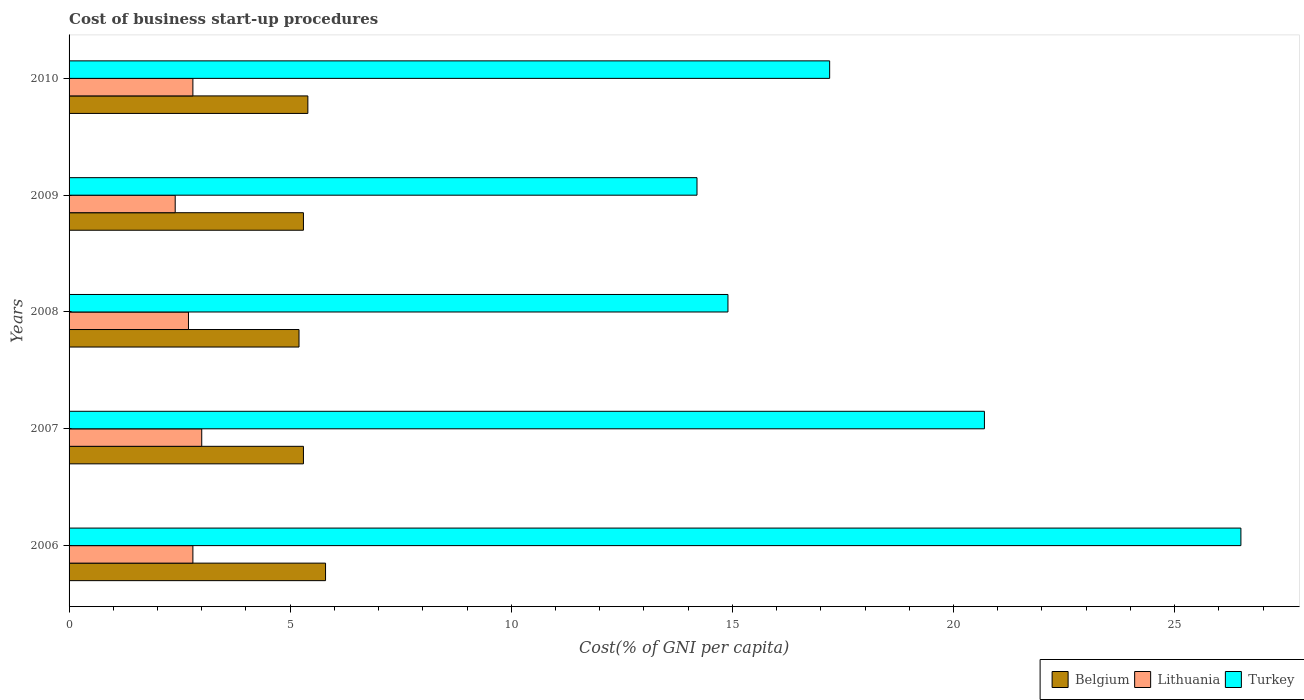How many groups of bars are there?
Provide a short and direct response. 5. Are the number of bars on each tick of the Y-axis equal?
Your answer should be compact. Yes. How many bars are there on the 4th tick from the top?
Your answer should be very brief. 3. What is the label of the 2nd group of bars from the top?
Your answer should be very brief. 2009. What is the total cost of business start-up procedures in Turkey in the graph?
Ensure brevity in your answer.  93.5. What is the difference between the cost of business start-up procedures in Belgium in 2008 and that in 2010?
Offer a very short reply. -0.2. What is the difference between the cost of business start-up procedures in Belgium in 2006 and the cost of business start-up procedures in Lithuania in 2008?
Give a very brief answer. 3.1. In the year 2006, what is the difference between the cost of business start-up procedures in Lithuania and cost of business start-up procedures in Belgium?
Keep it short and to the point. -3. In how many years, is the cost of business start-up procedures in Lithuania greater than 14 %?
Provide a succinct answer. 0. What is the ratio of the cost of business start-up procedures in Turkey in 2008 to that in 2009?
Ensure brevity in your answer.  1.05. Is the cost of business start-up procedures in Belgium in 2007 less than that in 2010?
Your response must be concise. Yes. Is the difference between the cost of business start-up procedures in Lithuania in 2006 and 2007 greater than the difference between the cost of business start-up procedures in Belgium in 2006 and 2007?
Offer a very short reply. No. What is the difference between the highest and the second highest cost of business start-up procedures in Lithuania?
Make the answer very short. 0.2. What is the difference between the highest and the lowest cost of business start-up procedures in Turkey?
Keep it short and to the point. 12.3. In how many years, is the cost of business start-up procedures in Belgium greater than the average cost of business start-up procedures in Belgium taken over all years?
Keep it short and to the point. 1. What does the 2nd bar from the top in 2008 represents?
Your answer should be very brief. Lithuania. What does the 1st bar from the bottom in 2006 represents?
Provide a succinct answer. Belgium. Is it the case that in every year, the sum of the cost of business start-up procedures in Lithuania and cost of business start-up procedures in Belgium is greater than the cost of business start-up procedures in Turkey?
Provide a succinct answer. No. What is the difference between two consecutive major ticks on the X-axis?
Ensure brevity in your answer.  5. Are the values on the major ticks of X-axis written in scientific E-notation?
Give a very brief answer. No. Does the graph contain any zero values?
Your response must be concise. No. Where does the legend appear in the graph?
Ensure brevity in your answer.  Bottom right. What is the title of the graph?
Your response must be concise. Cost of business start-up procedures. Does "Andorra" appear as one of the legend labels in the graph?
Make the answer very short. No. What is the label or title of the X-axis?
Provide a succinct answer. Cost(% of GNI per capita). What is the Cost(% of GNI per capita) of Belgium in 2006?
Your answer should be compact. 5.8. What is the Cost(% of GNI per capita) in Belgium in 2007?
Make the answer very short. 5.3. What is the Cost(% of GNI per capita) of Lithuania in 2007?
Keep it short and to the point. 3. What is the Cost(% of GNI per capita) of Turkey in 2007?
Give a very brief answer. 20.7. What is the Cost(% of GNI per capita) of Belgium in 2008?
Your answer should be very brief. 5.2. What is the Cost(% of GNI per capita) in Turkey in 2008?
Offer a very short reply. 14.9. What is the Cost(% of GNI per capita) of Belgium in 2009?
Give a very brief answer. 5.3. What is the Cost(% of GNI per capita) in Turkey in 2009?
Provide a succinct answer. 14.2. What is the Cost(% of GNI per capita) in Belgium in 2010?
Provide a succinct answer. 5.4. What is the Cost(% of GNI per capita) in Lithuania in 2010?
Provide a succinct answer. 2.8. Across all years, what is the maximum Cost(% of GNI per capita) in Lithuania?
Ensure brevity in your answer.  3. Across all years, what is the maximum Cost(% of GNI per capita) of Turkey?
Your answer should be compact. 26.5. Across all years, what is the minimum Cost(% of GNI per capita) of Lithuania?
Your answer should be compact. 2.4. What is the total Cost(% of GNI per capita) of Lithuania in the graph?
Ensure brevity in your answer.  13.7. What is the total Cost(% of GNI per capita) of Turkey in the graph?
Offer a very short reply. 93.5. What is the difference between the Cost(% of GNI per capita) in Lithuania in 2006 and that in 2007?
Offer a terse response. -0.2. What is the difference between the Cost(% of GNI per capita) of Lithuania in 2006 and that in 2008?
Provide a short and direct response. 0.1. What is the difference between the Cost(% of GNI per capita) of Turkey in 2006 and that in 2009?
Offer a very short reply. 12.3. What is the difference between the Cost(% of GNI per capita) in Belgium in 2006 and that in 2010?
Make the answer very short. 0.4. What is the difference between the Cost(% of GNI per capita) in Turkey in 2006 and that in 2010?
Offer a terse response. 9.3. What is the difference between the Cost(% of GNI per capita) of Belgium in 2007 and that in 2008?
Give a very brief answer. 0.1. What is the difference between the Cost(% of GNI per capita) of Lithuania in 2007 and that in 2009?
Ensure brevity in your answer.  0.6. What is the difference between the Cost(% of GNI per capita) of Turkey in 2007 and that in 2009?
Offer a terse response. 6.5. What is the difference between the Cost(% of GNI per capita) in Lithuania in 2007 and that in 2010?
Offer a terse response. 0.2. What is the difference between the Cost(% of GNI per capita) in Lithuania in 2009 and that in 2010?
Your answer should be very brief. -0.4. What is the difference between the Cost(% of GNI per capita) in Turkey in 2009 and that in 2010?
Your answer should be very brief. -3. What is the difference between the Cost(% of GNI per capita) in Belgium in 2006 and the Cost(% of GNI per capita) in Lithuania in 2007?
Make the answer very short. 2.8. What is the difference between the Cost(% of GNI per capita) in Belgium in 2006 and the Cost(% of GNI per capita) in Turkey in 2007?
Give a very brief answer. -14.9. What is the difference between the Cost(% of GNI per capita) of Lithuania in 2006 and the Cost(% of GNI per capita) of Turkey in 2007?
Your answer should be very brief. -17.9. What is the difference between the Cost(% of GNI per capita) of Lithuania in 2006 and the Cost(% of GNI per capita) of Turkey in 2008?
Provide a short and direct response. -12.1. What is the difference between the Cost(% of GNI per capita) in Belgium in 2006 and the Cost(% of GNI per capita) in Turkey in 2009?
Provide a succinct answer. -8.4. What is the difference between the Cost(% of GNI per capita) in Belgium in 2006 and the Cost(% of GNI per capita) in Turkey in 2010?
Offer a terse response. -11.4. What is the difference between the Cost(% of GNI per capita) of Lithuania in 2006 and the Cost(% of GNI per capita) of Turkey in 2010?
Offer a terse response. -14.4. What is the difference between the Cost(% of GNI per capita) in Belgium in 2007 and the Cost(% of GNI per capita) in Turkey in 2008?
Your answer should be very brief. -9.6. What is the difference between the Cost(% of GNI per capita) in Belgium in 2007 and the Cost(% of GNI per capita) in Lithuania in 2009?
Your answer should be very brief. 2.9. What is the difference between the Cost(% of GNI per capita) of Belgium in 2007 and the Cost(% of GNI per capita) of Turkey in 2009?
Keep it short and to the point. -8.9. What is the difference between the Cost(% of GNI per capita) in Belgium in 2007 and the Cost(% of GNI per capita) in Lithuania in 2010?
Your answer should be very brief. 2.5. What is the difference between the Cost(% of GNI per capita) in Belgium in 2007 and the Cost(% of GNI per capita) in Turkey in 2010?
Offer a terse response. -11.9. What is the difference between the Cost(% of GNI per capita) in Belgium in 2008 and the Cost(% of GNI per capita) in Lithuania in 2010?
Your answer should be very brief. 2.4. What is the difference between the Cost(% of GNI per capita) in Lithuania in 2008 and the Cost(% of GNI per capita) in Turkey in 2010?
Provide a succinct answer. -14.5. What is the difference between the Cost(% of GNI per capita) of Belgium in 2009 and the Cost(% of GNI per capita) of Turkey in 2010?
Make the answer very short. -11.9. What is the difference between the Cost(% of GNI per capita) of Lithuania in 2009 and the Cost(% of GNI per capita) of Turkey in 2010?
Provide a short and direct response. -14.8. What is the average Cost(% of GNI per capita) of Belgium per year?
Offer a very short reply. 5.4. What is the average Cost(% of GNI per capita) in Lithuania per year?
Ensure brevity in your answer.  2.74. What is the average Cost(% of GNI per capita) of Turkey per year?
Offer a very short reply. 18.7. In the year 2006, what is the difference between the Cost(% of GNI per capita) in Belgium and Cost(% of GNI per capita) in Turkey?
Give a very brief answer. -20.7. In the year 2006, what is the difference between the Cost(% of GNI per capita) of Lithuania and Cost(% of GNI per capita) of Turkey?
Make the answer very short. -23.7. In the year 2007, what is the difference between the Cost(% of GNI per capita) of Belgium and Cost(% of GNI per capita) of Turkey?
Ensure brevity in your answer.  -15.4. In the year 2007, what is the difference between the Cost(% of GNI per capita) in Lithuania and Cost(% of GNI per capita) in Turkey?
Ensure brevity in your answer.  -17.7. In the year 2008, what is the difference between the Cost(% of GNI per capita) in Belgium and Cost(% of GNI per capita) in Lithuania?
Make the answer very short. 2.5. In the year 2009, what is the difference between the Cost(% of GNI per capita) of Lithuania and Cost(% of GNI per capita) of Turkey?
Give a very brief answer. -11.8. In the year 2010, what is the difference between the Cost(% of GNI per capita) in Belgium and Cost(% of GNI per capita) in Turkey?
Provide a short and direct response. -11.8. In the year 2010, what is the difference between the Cost(% of GNI per capita) in Lithuania and Cost(% of GNI per capita) in Turkey?
Keep it short and to the point. -14.4. What is the ratio of the Cost(% of GNI per capita) of Belgium in 2006 to that in 2007?
Give a very brief answer. 1.09. What is the ratio of the Cost(% of GNI per capita) in Lithuania in 2006 to that in 2007?
Offer a terse response. 0.93. What is the ratio of the Cost(% of GNI per capita) in Turkey in 2006 to that in 2007?
Provide a short and direct response. 1.28. What is the ratio of the Cost(% of GNI per capita) in Belgium in 2006 to that in 2008?
Ensure brevity in your answer.  1.12. What is the ratio of the Cost(% of GNI per capita) in Turkey in 2006 to that in 2008?
Give a very brief answer. 1.78. What is the ratio of the Cost(% of GNI per capita) in Belgium in 2006 to that in 2009?
Offer a very short reply. 1.09. What is the ratio of the Cost(% of GNI per capita) of Turkey in 2006 to that in 2009?
Offer a very short reply. 1.87. What is the ratio of the Cost(% of GNI per capita) of Belgium in 2006 to that in 2010?
Offer a terse response. 1.07. What is the ratio of the Cost(% of GNI per capita) in Turkey in 2006 to that in 2010?
Offer a terse response. 1.54. What is the ratio of the Cost(% of GNI per capita) of Belgium in 2007 to that in 2008?
Keep it short and to the point. 1.02. What is the ratio of the Cost(% of GNI per capita) in Turkey in 2007 to that in 2008?
Your answer should be compact. 1.39. What is the ratio of the Cost(% of GNI per capita) of Belgium in 2007 to that in 2009?
Your response must be concise. 1. What is the ratio of the Cost(% of GNI per capita) in Lithuania in 2007 to that in 2009?
Your answer should be compact. 1.25. What is the ratio of the Cost(% of GNI per capita) in Turkey in 2007 to that in 2009?
Ensure brevity in your answer.  1.46. What is the ratio of the Cost(% of GNI per capita) in Belgium in 2007 to that in 2010?
Keep it short and to the point. 0.98. What is the ratio of the Cost(% of GNI per capita) of Lithuania in 2007 to that in 2010?
Your response must be concise. 1.07. What is the ratio of the Cost(% of GNI per capita) in Turkey in 2007 to that in 2010?
Offer a terse response. 1.2. What is the ratio of the Cost(% of GNI per capita) in Belgium in 2008 to that in 2009?
Make the answer very short. 0.98. What is the ratio of the Cost(% of GNI per capita) in Turkey in 2008 to that in 2009?
Offer a terse response. 1.05. What is the ratio of the Cost(% of GNI per capita) of Turkey in 2008 to that in 2010?
Provide a succinct answer. 0.87. What is the ratio of the Cost(% of GNI per capita) in Belgium in 2009 to that in 2010?
Keep it short and to the point. 0.98. What is the ratio of the Cost(% of GNI per capita) in Turkey in 2009 to that in 2010?
Your answer should be compact. 0.83. What is the difference between the highest and the second highest Cost(% of GNI per capita) in Belgium?
Offer a very short reply. 0.4. What is the difference between the highest and the second highest Cost(% of GNI per capita) in Lithuania?
Provide a short and direct response. 0.2. What is the difference between the highest and the second highest Cost(% of GNI per capita) of Turkey?
Provide a short and direct response. 5.8. 